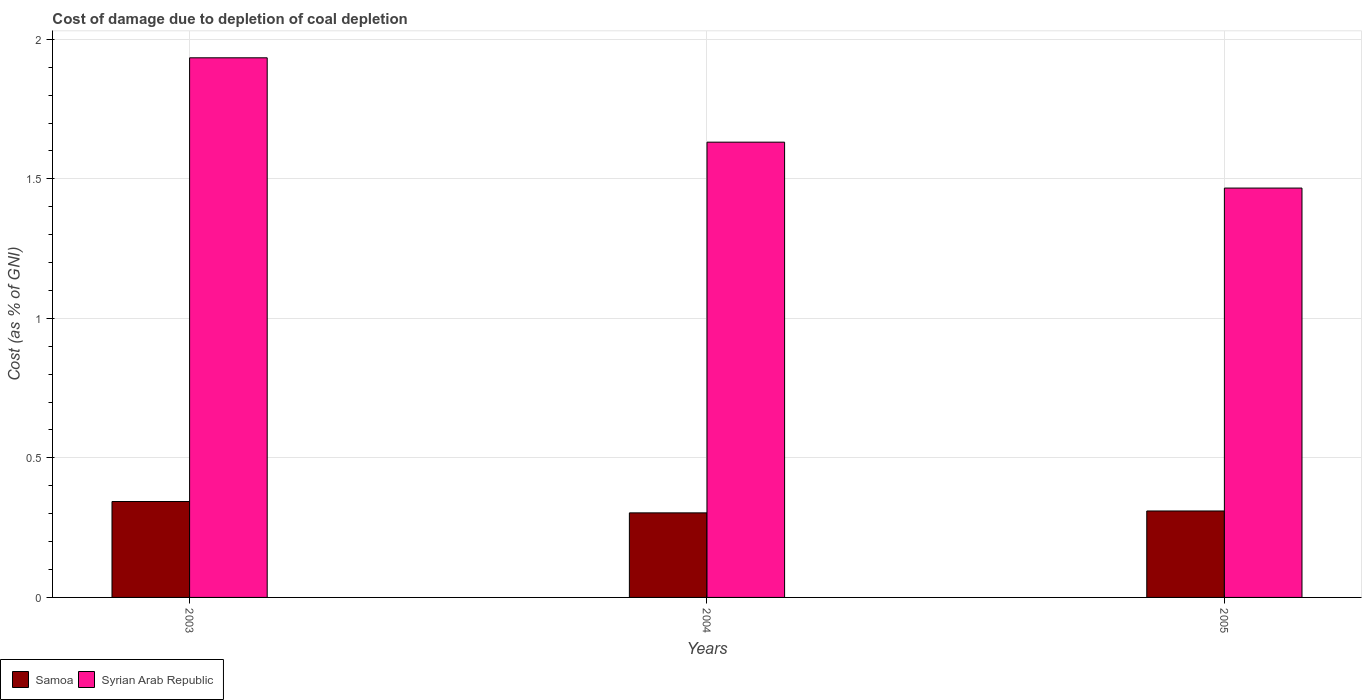Are the number of bars on each tick of the X-axis equal?
Your answer should be compact. Yes. How many bars are there on the 2nd tick from the left?
Your answer should be very brief. 2. How many bars are there on the 2nd tick from the right?
Provide a short and direct response. 2. What is the label of the 1st group of bars from the left?
Your answer should be very brief. 2003. In how many cases, is the number of bars for a given year not equal to the number of legend labels?
Offer a very short reply. 0. What is the cost of damage caused due to coal depletion in Syrian Arab Republic in 2003?
Make the answer very short. 1.93. Across all years, what is the maximum cost of damage caused due to coal depletion in Syrian Arab Republic?
Ensure brevity in your answer.  1.93. Across all years, what is the minimum cost of damage caused due to coal depletion in Samoa?
Your response must be concise. 0.3. In which year was the cost of damage caused due to coal depletion in Syrian Arab Republic minimum?
Provide a succinct answer. 2005. What is the total cost of damage caused due to coal depletion in Syrian Arab Republic in the graph?
Offer a very short reply. 5.03. What is the difference between the cost of damage caused due to coal depletion in Samoa in 2004 and that in 2005?
Offer a very short reply. -0.01. What is the difference between the cost of damage caused due to coal depletion in Samoa in 2005 and the cost of damage caused due to coal depletion in Syrian Arab Republic in 2004?
Keep it short and to the point. -1.32. What is the average cost of damage caused due to coal depletion in Samoa per year?
Offer a very short reply. 0.32. In the year 2004, what is the difference between the cost of damage caused due to coal depletion in Syrian Arab Republic and cost of damage caused due to coal depletion in Samoa?
Your answer should be very brief. 1.33. In how many years, is the cost of damage caused due to coal depletion in Syrian Arab Republic greater than 1.8 %?
Make the answer very short. 1. What is the ratio of the cost of damage caused due to coal depletion in Samoa in 2003 to that in 2004?
Ensure brevity in your answer.  1.13. Is the cost of damage caused due to coal depletion in Samoa in 2004 less than that in 2005?
Give a very brief answer. Yes. What is the difference between the highest and the second highest cost of damage caused due to coal depletion in Samoa?
Offer a terse response. 0.03. What is the difference between the highest and the lowest cost of damage caused due to coal depletion in Samoa?
Offer a terse response. 0.04. In how many years, is the cost of damage caused due to coal depletion in Syrian Arab Republic greater than the average cost of damage caused due to coal depletion in Syrian Arab Republic taken over all years?
Your response must be concise. 1. What does the 1st bar from the left in 2005 represents?
Make the answer very short. Samoa. What does the 2nd bar from the right in 2003 represents?
Your answer should be very brief. Samoa. Are all the bars in the graph horizontal?
Ensure brevity in your answer.  No. What is the difference between two consecutive major ticks on the Y-axis?
Your response must be concise. 0.5. Does the graph contain any zero values?
Make the answer very short. No. How many legend labels are there?
Ensure brevity in your answer.  2. What is the title of the graph?
Offer a very short reply. Cost of damage due to depletion of coal depletion. Does "Azerbaijan" appear as one of the legend labels in the graph?
Provide a short and direct response. No. What is the label or title of the X-axis?
Ensure brevity in your answer.  Years. What is the label or title of the Y-axis?
Offer a very short reply. Cost (as % of GNI). What is the Cost (as % of GNI) of Samoa in 2003?
Your response must be concise. 0.34. What is the Cost (as % of GNI) of Syrian Arab Republic in 2003?
Your answer should be compact. 1.93. What is the Cost (as % of GNI) in Samoa in 2004?
Provide a succinct answer. 0.3. What is the Cost (as % of GNI) in Syrian Arab Republic in 2004?
Ensure brevity in your answer.  1.63. What is the Cost (as % of GNI) in Samoa in 2005?
Your answer should be very brief. 0.31. What is the Cost (as % of GNI) of Syrian Arab Republic in 2005?
Keep it short and to the point. 1.47. Across all years, what is the maximum Cost (as % of GNI) in Samoa?
Your response must be concise. 0.34. Across all years, what is the maximum Cost (as % of GNI) of Syrian Arab Republic?
Give a very brief answer. 1.93. Across all years, what is the minimum Cost (as % of GNI) of Samoa?
Your answer should be very brief. 0.3. Across all years, what is the minimum Cost (as % of GNI) in Syrian Arab Republic?
Offer a very short reply. 1.47. What is the total Cost (as % of GNI) in Samoa in the graph?
Offer a very short reply. 0.96. What is the total Cost (as % of GNI) of Syrian Arab Republic in the graph?
Provide a succinct answer. 5.03. What is the difference between the Cost (as % of GNI) of Samoa in 2003 and that in 2004?
Give a very brief answer. 0.04. What is the difference between the Cost (as % of GNI) in Syrian Arab Republic in 2003 and that in 2004?
Ensure brevity in your answer.  0.3. What is the difference between the Cost (as % of GNI) of Samoa in 2003 and that in 2005?
Your answer should be very brief. 0.03. What is the difference between the Cost (as % of GNI) in Syrian Arab Republic in 2003 and that in 2005?
Provide a succinct answer. 0.47. What is the difference between the Cost (as % of GNI) in Samoa in 2004 and that in 2005?
Provide a succinct answer. -0.01. What is the difference between the Cost (as % of GNI) of Syrian Arab Republic in 2004 and that in 2005?
Offer a terse response. 0.16. What is the difference between the Cost (as % of GNI) of Samoa in 2003 and the Cost (as % of GNI) of Syrian Arab Republic in 2004?
Offer a very short reply. -1.29. What is the difference between the Cost (as % of GNI) of Samoa in 2003 and the Cost (as % of GNI) of Syrian Arab Republic in 2005?
Provide a short and direct response. -1.12. What is the difference between the Cost (as % of GNI) of Samoa in 2004 and the Cost (as % of GNI) of Syrian Arab Republic in 2005?
Your answer should be compact. -1.16. What is the average Cost (as % of GNI) of Samoa per year?
Your response must be concise. 0.32. What is the average Cost (as % of GNI) of Syrian Arab Republic per year?
Your response must be concise. 1.68. In the year 2003, what is the difference between the Cost (as % of GNI) of Samoa and Cost (as % of GNI) of Syrian Arab Republic?
Your answer should be very brief. -1.59. In the year 2004, what is the difference between the Cost (as % of GNI) in Samoa and Cost (as % of GNI) in Syrian Arab Republic?
Ensure brevity in your answer.  -1.33. In the year 2005, what is the difference between the Cost (as % of GNI) in Samoa and Cost (as % of GNI) in Syrian Arab Republic?
Ensure brevity in your answer.  -1.16. What is the ratio of the Cost (as % of GNI) in Samoa in 2003 to that in 2004?
Offer a very short reply. 1.13. What is the ratio of the Cost (as % of GNI) in Syrian Arab Republic in 2003 to that in 2004?
Your response must be concise. 1.19. What is the ratio of the Cost (as % of GNI) of Samoa in 2003 to that in 2005?
Offer a very short reply. 1.11. What is the ratio of the Cost (as % of GNI) of Syrian Arab Republic in 2003 to that in 2005?
Make the answer very short. 1.32. What is the ratio of the Cost (as % of GNI) of Samoa in 2004 to that in 2005?
Give a very brief answer. 0.98. What is the ratio of the Cost (as % of GNI) of Syrian Arab Republic in 2004 to that in 2005?
Ensure brevity in your answer.  1.11. What is the difference between the highest and the second highest Cost (as % of GNI) in Samoa?
Your response must be concise. 0.03. What is the difference between the highest and the second highest Cost (as % of GNI) of Syrian Arab Republic?
Your answer should be very brief. 0.3. What is the difference between the highest and the lowest Cost (as % of GNI) in Samoa?
Provide a short and direct response. 0.04. What is the difference between the highest and the lowest Cost (as % of GNI) in Syrian Arab Republic?
Keep it short and to the point. 0.47. 